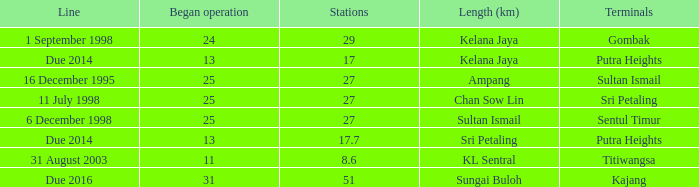When did the first initiation of operation occur with a length of sultan ismail and beyond 27 stations? None. 